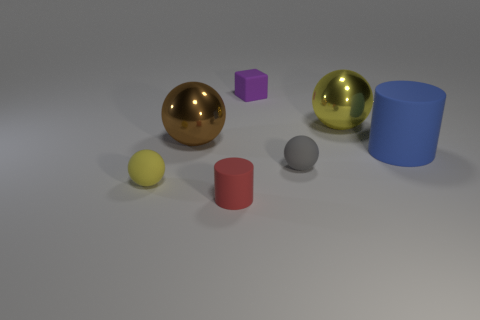Add 2 tiny cyan shiny cylinders. How many objects exist? 9 Subtract all yellow rubber spheres. How many spheres are left? 3 Subtract all balls. How many objects are left? 3 Subtract 1 balls. How many balls are left? 3 Subtract 0 red cubes. How many objects are left? 7 Subtract all gray spheres. Subtract all purple cubes. How many spheres are left? 3 Subtract all purple balls. How many red cylinders are left? 1 Subtract all blue cylinders. Subtract all blue objects. How many objects are left? 5 Add 5 big blue rubber cylinders. How many big blue rubber cylinders are left? 6 Add 3 yellow matte balls. How many yellow matte balls exist? 4 